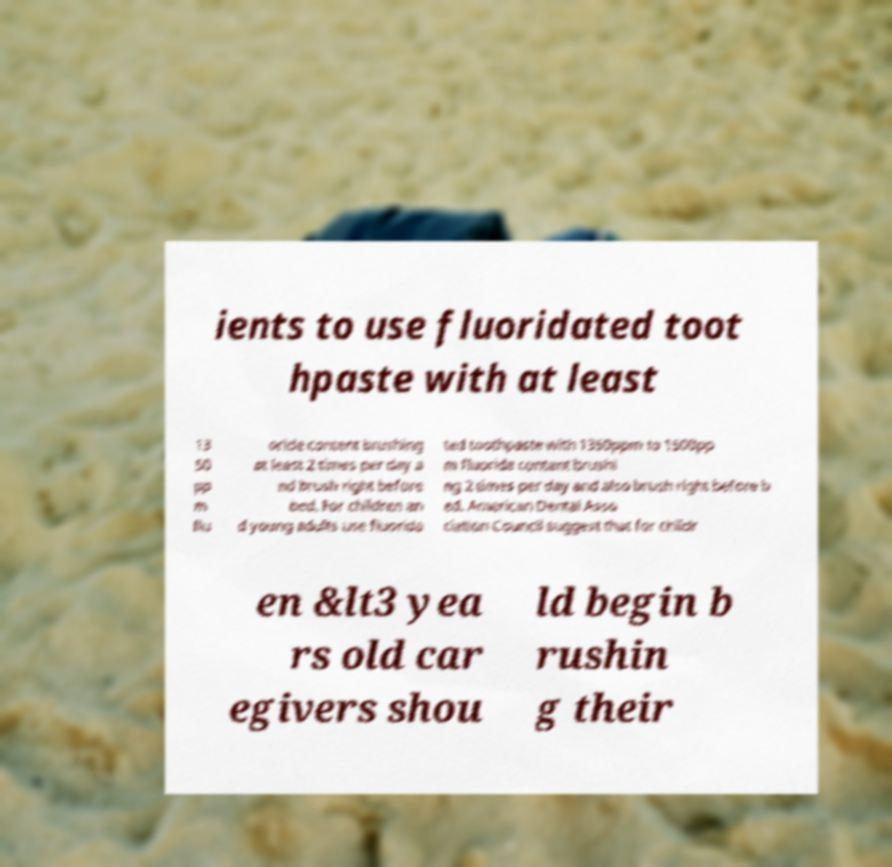Please read and relay the text visible in this image. What does it say? ients to use fluoridated toot hpaste with at least 13 50 pp m flu oride content brushing at least 2 times per day a nd brush right before bed. For children an d young adults use fluorida ted toothpaste with 1350ppm to 1500pp m fluoride content brushi ng 2 times per day and also brush right before b ed. American Dental Asso ciation Council suggest that for childr en &lt3 yea rs old car egivers shou ld begin b rushin g their 